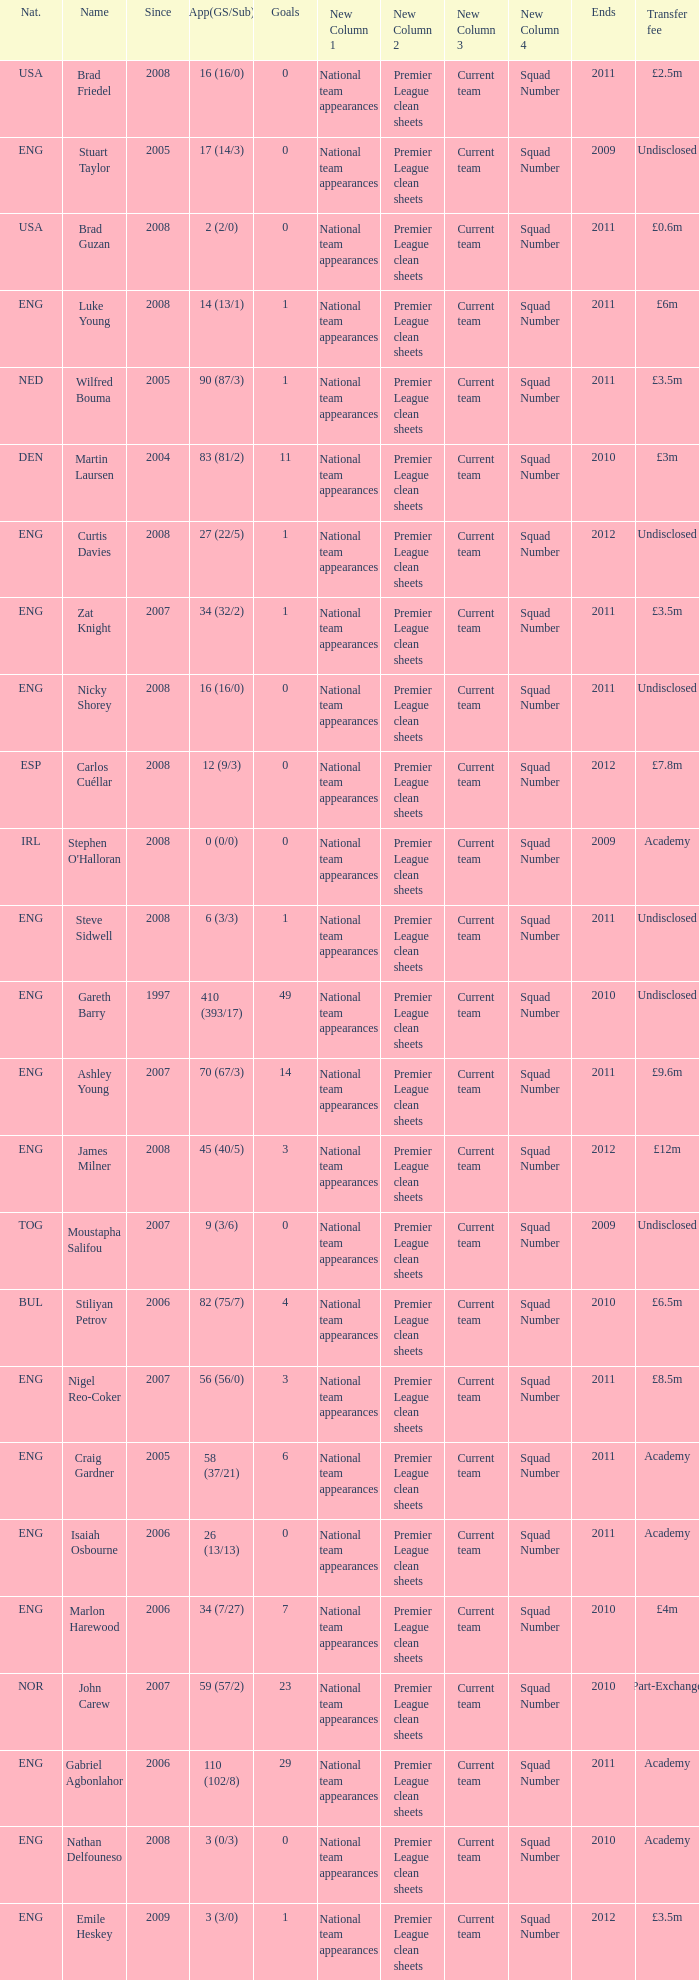What is the greatest goals for Curtis Davies if ends is greater than 2012? None. 